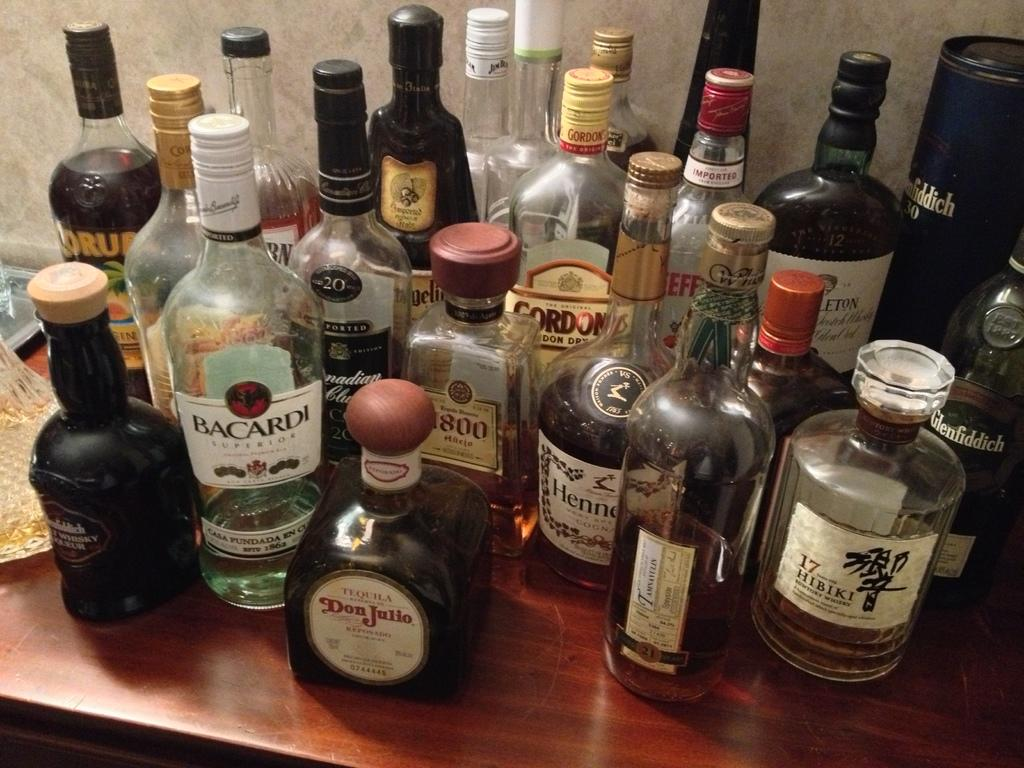Provide a one-sentence caption for the provided image. a lot of liquor bottles, with a bottle of Barcardi near the front left. 